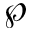<formula> <loc_0><loc_0><loc_500><loc_500>\wp</formula> 